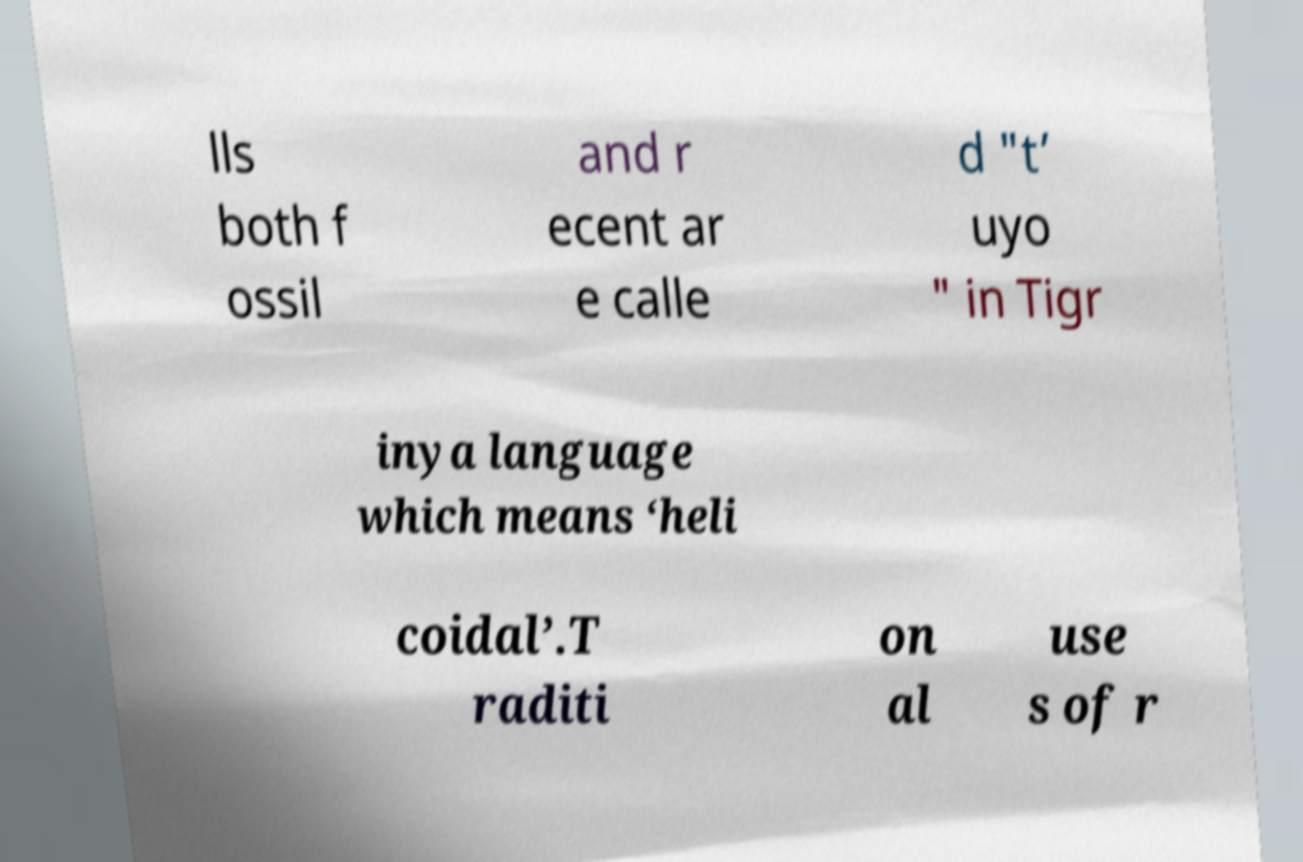Please identify and transcribe the text found in this image. lls both f ossil and r ecent ar e calle d "t’ uyo " in Tigr inya language which means ‘heli coidal’.T raditi on al use s of r 